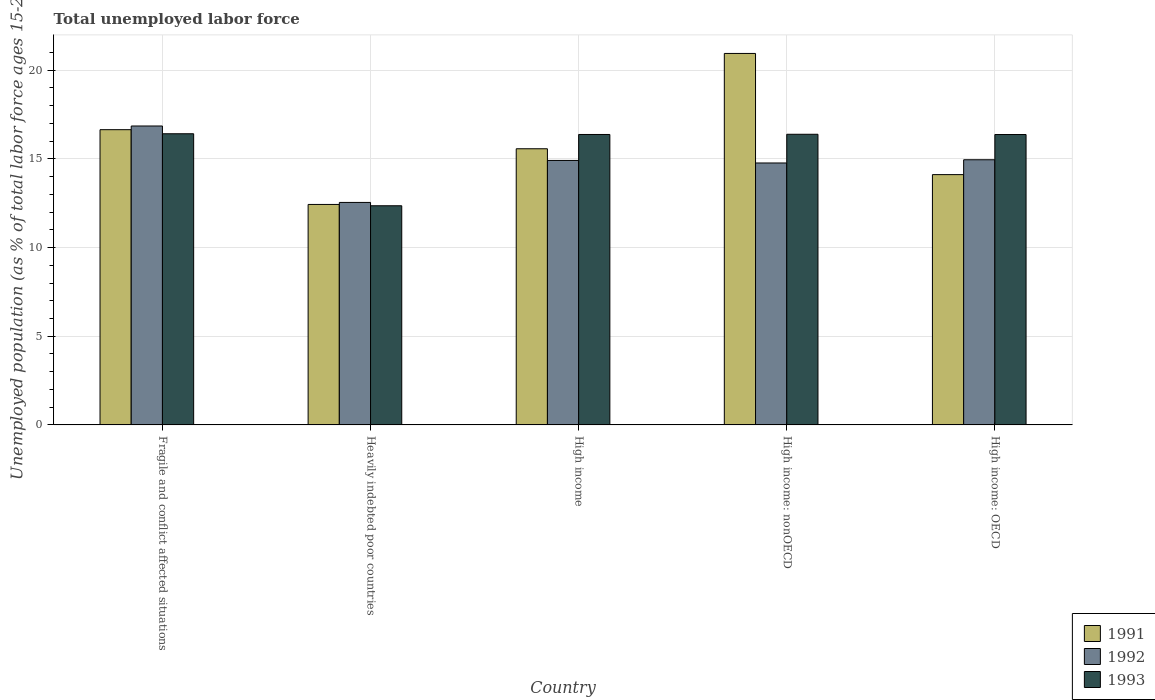How many groups of bars are there?
Ensure brevity in your answer.  5. Are the number of bars on each tick of the X-axis equal?
Make the answer very short. Yes. How many bars are there on the 2nd tick from the right?
Make the answer very short. 3. What is the label of the 2nd group of bars from the left?
Provide a short and direct response. Heavily indebted poor countries. In how many cases, is the number of bars for a given country not equal to the number of legend labels?
Offer a terse response. 0. What is the percentage of unemployed population in in 1991 in High income: nonOECD?
Your answer should be very brief. 20.94. Across all countries, what is the maximum percentage of unemployed population in in 1993?
Give a very brief answer. 16.42. Across all countries, what is the minimum percentage of unemployed population in in 1992?
Keep it short and to the point. 12.54. In which country was the percentage of unemployed population in in 1993 maximum?
Your answer should be compact. Fragile and conflict affected situations. In which country was the percentage of unemployed population in in 1992 minimum?
Offer a terse response. Heavily indebted poor countries. What is the total percentage of unemployed population in in 1991 in the graph?
Offer a very short reply. 79.7. What is the difference between the percentage of unemployed population in in 1993 in Heavily indebted poor countries and that in High income: nonOECD?
Your answer should be very brief. -4.03. What is the difference between the percentage of unemployed population in in 1991 in High income and the percentage of unemployed population in in 1993 in High income: OECD?
Provide a succinct answer. -0.8. What is the average percentage of unemployed population in in 1993 per country?
Give a very brief answer. 15.58. What is the difference between the percentage of unemployed population in of/in 1993 and percentage of unemployed population in of/in 1991 in Fragile and conflict affected situations?
Provide a short and direct response. -0.23. What is the ratio of the percentage of unemployed population in in 1993 in Heavily indebted poor countries to that in High income: nonOECD?
Provide a succinct answer. 0.75. Is the percentage of unemployed population in in 1991 in Fragile and conflict affected situations less than that in High income: nonOECD?
Your answer should be very brief. Yes. What is the difference between the highest and the second highest percentage of unemployed population in in 1991?
Your answer should be very brief. -4.3. What is the difference between the highest and the lowest percentage of unemployed population in in 1993?
Offer a terse response. 4.06. In how many countries, is the percentage of unemployed population in in 1993 greater than the average percentage of unemployed population in in 1993 taken over all countries?
Offer a very short reply. 4. What does the 2nd bar from the left in Heavily indebted poor countries represents?
Offer a terse response. 1992. What does the 2nd bar from the right in High income represents?
Make the answer very short. 1992. Are all the bars in the graph horizontal?
Offer a very short reply. No. How many countries are there in the graph?
Ensure brevity in your answer.  5. What is the difference between two consecutive major ticks on the Y-axis?
Offer a very short reply. 5. Does the graph contain grids?
Your answer should be compact. Yes. How are the legend labels stacked?
Offer a very short reply. Vertical. What is the title of the graph?
Offer a very short reply. Total unemployed labor force. What is the label or title of the Y-axis?
Your answer should be very brief. Unemployed population (as % of total labor force ages 15-24). What is the Unemployed population (as % of total labor force ages 15-24) of 1991 in Fragile and conflict affected situations?
Provide a short and direct response. 16.65. What is the Unemployed population (as % of total labor force ages 15-24) of 1992 in Fragile and conflict affected situations?
Provide a succinct answer. 16.85. What is the Unemployed population (as % of total labor force ages 15-24) in 1993 in Fragile and conflict affected situations?
Give a very brief answer. 16.42. What is the Unemployed population (as % of total labor force ages 15-24) of 1991 in Heavily indebted poor countries?
Ensure brevity in your answer.  12.43. What is the Unemployed population (as % of total labor force ages 15-24) in 1992 in Heavily indebted poor countries?
Keep it short and to the point. 12.54. What is the Unemployed population (as % of total labor force ages 15-24) in 1993 in Heavily indebted poor countries?
Keep it short and to the point. 12.36. What is the Unemployed population (as % of total labor force ages 15-24) of 1991 in High income?
Provide a succinct answer. 15.57. What is the Unemployed population (as % of total labor force ages 15-24) in 1992 in High income?
Provide a short and direct response. 14.91. What is the Unemployed population (as % of total labor force ages 15-24) of 1993 in High income?
Your response must be concise. 16.38. What is the Unemployed population (as % of total labor force ages 15-24) in 1991 in High income: nonOECD?
Your answer should be very brief. 20.94. What is the Unemployed population (as % of total labor force ages 15-24) in 1992 in High income: nonOECD?
Your answer should be very brief. 14.77. What is the Unemployed population (as % of total labor force ages 15-24) in 1993 in High income: nonOECD?
Offer a very short reply. 16.39. What is the Unemployed population (as % of total labor force ages 15-24) of 1991 in High income: OECD?
Make the answer very short. 14.11. What is the Unemployed population (as % of total labor force ages 15-24) in 1992 in High income: OECD?
Offer a very short reply. 14.95. What is the Unemployed population (as % of total labor force ages 15-24) of 1993 in High income: OECD?
Offer a terse response. 16.37. Across all countries, what is the maximum Unemployed population (as % of total labor force ages 15-24) in 1991?
Your answer should be compact. 20.94. Across all countries, what is the maximum Unemployed population (as % of total labor force ages 15-24) in 1992?
Provide a succinct answer. 16.85. Across all countries, what is the maximum Unemployed population (as % of total labor force ages 15-24) of 1993?
Your answer should be compact. 16.42. Across all countries, what is the minimum Unemployed population (as % of total labor force ages 15-24) in 1991?
Your answer should be compact. 12.43. Across all countries, what is the minimum Unemployed population (as % of total labor force ages 15-24) of 1992?
Give a very brief answer. 12.54. Across all countries, what is the minimum Unemployed population (as % of total labor force ages 15-24) in 1993?
Keep it short and to the point. 12.36. What is the total Unemployed population (as % of total labor force ages 15-24) of 1991 in the graph?
Offer a terse response. 79.7. What is the total Unemployed population (as % of total labor force ages 15-24) in 1992 in the graph?
Provide a succinct answer. 74.03. What is the total Unemployed population (as % of total labor force ages 15-24) in 1993 in the graph?
Give a very brief answer. 77.91. What is the difference between the Unemployed population (as % of total labor force ages 15-24) of 1991 in Fragile and conflict affected situations and that in Heavily indebted poor countries?
Keep it short and to the point. 4.22. What is the difference between the Unemployed population (as % of total labor force ages 15-24) of 1992 in Fragile and conflict affected situations and that in Heavily indebted poor countries?
Keep it short and to the point. 4.31. What is the difference between the Unemployed population (as % of total labor force ages 15-24) of 1993 in Fragile and conflict affected situations and that in Heavily indebted poor countries?
Offer a terse response. 4.06. What is the difference between the Unemployed population (as % of total labor force ages 15-24) in 1991 in Fragile and conflict affected situations and that in High income?
Provide a succinct answer. 1.08. What is the difference between the Unemployed population (as % of total labor force ages 15-24) in 1992 in Fragile and conflict affected situations and that in High income?
Provide a short and direct response. 1.94. What is the difference between the Unemployed population (as % of total labor force ages 15-24) in 1993 in Fragile and conflict affected situations and that in High income?
Give a very brief answer. 0.04. What is the difference between the Unemployed population (as % of total labor force ages 15-24) of 1991 in Fragile and conflict affected situations and that in High income: nonOECD?
Your response must be concise. -4.3. What is the difference between the Unemployed population (as % of total labor force ages 15-24) of 1992 in Fragile and conflict affected situations and that in High income: nonOECD?
Give a very brief answer. 2.09. What is the difference between the Unemployed population (as % of total labor force ages 15-24) of 1993 in Fragile and conflict affected situations and that in High income: nonOECD?
Make the answer very short. 0.03. What is the difference between the Unemployed population (as % of total labor force ages 15-24) in 1991 in Fragile and conflict affected situations and that in High income: OECD?
Your response must be concise. 2.53. What is the difference between the Unemployed population (as % of total labor force ages 15-24) in 1992 in Fragile and conflict affected situations and that in High income: OECD?
Your response must be concise. 1.9. What is the difference between the Unemployed population (as % of total labor force ages 15-24) in 1993 in Fragile and conflict affected situations and that in High income: OECD?
Give a very brief answer. 0.04. What is the difference between the Unemployed population (as % of total labor force ages 15-24) in 1991 in Heavily indebted poor countries and that in High income?
Make the answer very short. -3.14. What is the difference between the Unemployed population (as % of total labor force ages 15-24) of 1992 in Heavily indebted poor countries and that in High income?
Keep it short and to the point. -2.37. What is the difference between the Unemployed population (as % of total labor force ages 15-24) of 1993 in Heavily indebted poor countries and that in High income?
Ensure brevity in your answer.  -4.02. What is the difference between the Unemployed population (as % of total labor force ages 15-24) in 1991 in Heavily indebted poor countries and that in High income: nonOECD?
Offer a very short reply. -8.51. What is the difference between the Unemployed population (as % of total labor force ages 15-24) of 1992 in Heavily indebted poor countries and that in High income: nonOECD?
Your answer should be compact. -2.22. What is the difference between the Unemployed population (as % of total labor force ages 15-24) of 1993 in Heavily indebted poor countries and that in High income: nonOECD?
Ensure brevity in your answer.  -4.03. What is the difference between the Unemployed population (as % of total labor force ages 15-24) of 1991 in Heavily indebted poor countries and that in High income: OECD?
Make the answer very short. -1.68. What is the difference between the Unemployed population (as % of total labor force ages 15-24) in 1992 in Heavily indebted poor countries and that in High income: OECD?
Offer a very short reply. -2.41. What is the difference between the Unemployed population (as % of total labor force ages 15-24) in 1993 in Heavily indebted poor countries and that in High income: OECD?
Keep it short and to the point. -4.02. What is the difference between the Unemployed population (as % of total labor force ages 15-24) in 1991 in High income and that in High income: nonOECD?
Ensure brevity in your answer.  -5.37. What is the difference between the Unemployed population (as % of total labor force ages 15-24) in 1992 in High income and that in High income: nonOECD?
Your answer should be compact. 0.14. What is the difference between the Unemployed population (as % of total labor force ages 15-24) of 1993 in High income and that in High income: nonOECD?
Your response must be concise. -0.01. What is the difference between the Unemployed population (as % of total labor force ages 15-24) of 1991 in High income and that in High income: OECD?
Provide a short and direct response. 1.46. What is the difference between the Unemployed population (as % of total labor force ages 15-24) in 1992 in High income and that in High income: OECD?
Ensure brevity in your answer.  -0.04. What is the difference between the Unemployed population (as % of total labor force ages 15-24) of 1993 in High income and that in High income: OECD?
Give a very brief answer. 0. What is the difference between the Unemployed population (as % of total labor force ages 15-24) in 1991 in High income: nonOECD and that in High income: OECD?
Ensure brevity in your answer.  6.83. What is the difference between the Unemployed population (as % of total labor force ages 15-24) of 1992 in High income: nonOECD and that in High income: OECD?
Your answer should be very brief. -0.18. What is the difference between the Unemployed population (as % of total labor force ages 15-24) of 1993 in High income: nonOECD and that in High income: OECD?
Ensure brevity in your answer.  0.01. What is the difference between the Unemployed population (as % of total labor force ages 15-24) of 1991 in Fragile and conflict affected situations and the Unemployed population (as % of total labor force ages 15-24) of 1992 in Heavily indebted poor countries?
Ensure brevity in your answer.  4.1. What is the difference between the Unemployed population (as % of total labor force ages 15-24) of 1991 in Fragile and conflict affected situations and the Unemployed population (as % of total labor force ages 15-24) of 1993 in Heavily indebted poor countries?
Give a very brief answer. 4.29. What is the difference between the Unemployed population (as % of total labor force ages 15-24) of 1992 in Fragile and conflict affected situations and the Unemployed population (as % of total labor force ages 15-24) of 1993 in Heavily indebted poor countries?
Offer a terse response. 4.5. What is the difference between the Unemployed population (as % of total labor force ages 15-24) in 1991 in Fragile and conflict affected situations and the Unemployed population (as % of total labor force ages 15-24) in 1992 in High income?
Your answer should be compact. 1.73. What is the difference between the Unemployed population (as % of total labor force ages 15-24) in 1991 in Fragile and conflict affected situations and the Unemployed population (as % of total labor force ages 15-24) in 1993 in High income?
Keep it short and to the point. 0.27. What is the difference between the Unemployed population (as % of total labor force ages 15-24) of 1992 in Fragile and conflict affected situations and the Unemployed population (as % of total labor force ages 15-24) of 1993 in High income?
Your response must be concise. 0.48. What is the difference between the Unemployed population (as % of total labor force ages 15-24) of 1991 in Fragile and conflict affected situations and the Unemployed population (as % of total labor force ages 15-24) of 1992 in High income: nonOECD?
Your answer should be very brief. 1.88. What is the difference between the Unemployed population (as % of total labor force ages 15-24) in 1991 in Fragile and conflict affected situations and the Unemployed population (as % of total labor force ages 15-24) in 1993 in High income: nonOECD?
Give a very brief answer. 0.26. What is the difference between the Unemployed population (as % of total labor force ages 15-24) in 1992 in Fragile and conflict affected situations and the Unemployed population (as % of total labor force ages 15-24) in 1993 in High income: nonOECD?
Ensure brevity in your answer.  0.47. What is the difference between the Unemployed population (as % of total labor force ages 15-24) of 1991 in Fragile and conflict affected situations and the Unemployed population (as % of total labor force ages 15-24) of 1992 in High income: OECD?
Make the answer very short. 1.7. What is the difference between the Unemployed population (as % of total labor force ages 15-24) in 1991 in Fragile and conflict affected situations and the Unemployed population (as % of total labor force ages 15-24) in 1993 in High income: OECD?
Your response must be concise. 0.27. What is the difference between the Unemployed population (as % of total labor force ages 15-24) of 1992 in Fragile and conflict affected situations and the Unemployed population (as % of total labor force ages 15-24) of 1993 in High income: OECD?
Your answer should be compact. 0.48. What is the difference between the Unemployed population (as % of total labor force ages 15-24) of 1991 in Heavily indebted poor countries and the Unemployed population (as % of total labor force ages 15-24) of 1992 in High income?
Provide a short and direct response. -2.48. What is the difference between the Unemployed population (as % of total labor force ages 15-24) in 1991 in Heavily indebted poor countries and the Unemployed population (as % of total labor force ages 15-24) in 1993 in High income?
Your answer should be compact. -3.95. What is the difference between the Unemployed population (as % of total labor force ages 15-24) of 1992 in Heavily indebted poor countries and the Unemployed population (as % of total labor force ages 15-24) of 1993 in High income?
Offer a terse response. -3.83. What is the difference between the Unemployed population (as % of total labor force ages 15-24) in 1991 in Heavily indebted poor countries and the Unemployed population (as % of total labor force ages 15-24) in 1992 in High income: nonOECD?
Provide a succinct answer. -2.34. What is the difference between the Unemployed population (as % of total labor force ages 15-24) of 1991 in Heavily indebted poor countries and the Unemployed population (as % of total labor force ages 15-24) of 1993 in High income: nonOECD?
Provide a succinct answer. -3.96. What is the difference between the Unemployed population (as % of total labor force ages 15-24) in 1992 in Heavily indebted poor countries and the Unemployed population (as % of total labor force ages 15-24) in 1993 in High income: nonOECD?
Your response must be concise. -3.84. What is the difference between the Unemployed population (as % of total labor force ages 15-24) in 1991 in Heavily indebted poor countries and the Unemployed population (as % of total labor force ages 15-24) in 1992 in High income: OECD?
Provide a short and direct response. -2.52. What is the difference between the Unemployed population (as % of total labor force ages 15-24) in 1991 in Heavily indebted poor countries and the Unemployed population (as % of total labor force ages 15-24) in 1993 in High income: OECD?
Provide a short and direct response. -3.94. What is the difference between the Unemployed population (as % of total labor force ages 15-24) of 1992 in Heavily indebted poor countries and the Unemployed population (as % of total labor force ages 15-24) of 1993 in High income: OECD?
Your answer should be compact. -3.83. What is the difference between the Unemployed population (as % of total labor force ages 15-24) in 1991 in High income and the Unemployed population (as % of total labor force ages 15-24) in 1992 in High income: nonOECD?
Your answer should be very brief. 0.8. What is the difference between the Unemployed population (as % of total labor force ages 15-24) of 1991 in High income and the Unemployed population (as % of total labor force ages 15-24) of 1993 in High income: nonOECD?
Provide a short and direct response. -0.82. What is the difference between the Unemployed population (as % of total labor force ages 15-24) of 1992 in High income and the Unemployed population (as % of total labor force ages 15-24) of 1993 in High income: nonOECD?
Offer a terse response. -1.48. What is the difference between the Unemployed population (as % of total labor force ages 15-24) in 1991 in High income and the Unemployed population (as % of total labor force ages 15-24) in 1992 in High income: OECD?
Give a very brief answer. 0.62. What is the difference between the Unemployed population (as % of total labor force ages 15-24) in 1991 in High income and the Unemployed population (as % of total labor force ages 15-24) in 1993 in High income: OECD?
Your answer should be very brief. -0.8. What is the difference between the Unemployed population (as % of total labor force ages 15-24) in 1992 in High income and the Unemployed population (as % of total labor force ages 15-24) in 1993 in High income: OECD?
Your answer should be very brief. -1.46. What is the difference between the Unemployed population (as % of total labor force ages 15-24) of 1991 in High income: nonOECD and the Unemployed population (as % of total labor force ages 15-24) of 1992 in High income: OECD?
Make the answer very short. 5.99. What is the difference between the Unemployed population (as % of total labor force ages 15-24) of 1991 in High income: nonOECD and the Unemployed population (as % of total labor force ages 15-24) of 1993 in High income: OECD?
Give a very brief answer. 4.57. What is the difference between the Unemployed population (as % of total labor force ages 15-24) in 1992 in High income: nonOECD and the Unemployed population (as % of total labor force ages 15-24) in 1993 in High income: OECD?
Offer a very short reply. -1.6. What is the average Unemployed population (as % of total labor force ages 15-24) of 1991 per country?
Ensure brevity in your answer.  15.94. What is the average Unemployed population (as % of total labor force ages 15-24) in 1992 per country?
Your answer should be compact. 14.81. What is the average Unemployed population (as % of total labor force ages 15-24) of 1993 per country?
Keep it short and to the point. 15.58. What is the difference between the Unemployed population (as % of total labor force ages 15-24) in 1991 and Unemployed population (as % of total labor force ages 15-24) in 1992 in Fragile and conflict affected situations?
Ensure brevity in your answer.  -0.21. What is the difference between the Unemployed population (as % of total labor force ages 15-24) in 1991 and Unemployed population (as % of total labor force ages 15-24) in 1993 in Fragile and conflict affected situations?
Ensure brevity in your answer.  0.23. What is the difference between the Unemployed population (as % of total labor force ages 15-24) in 1992 and Unemployed population (as % of total labor force ages 15-24) in 1993 in Fragile and conflict affected situations?
Your response must be concise. 0.44. What is the difference between the Unemployed population (as % of total labor force ages 15-24) of 1991 and Unemployed population (as % of total labor force ages 15-24) of 1992 in Heavily indebted poor countries?
Offer a very short reply. -0.11. What is the difference between the Unemployed population (as % of total labor force ages 15-24) of 1991 and Unemployed population (as % of total labor force ages 15-24) of 1993 in Heavily indebted poor countries?
Make the answer very short. 0.07. What is the difference between the Unemployed population (as % of total labor force ages 15-24) of 1992 and Unemployed population (as % of total labor force ages 15-24) of 1993 in Heavily indebted poor countries?
Give a very brief answer. 0.19. What is the difference between the Unemployed population (as % of total labor force ages 15-24) of 1991 and Unemployed population (as % of total labor force ages 15-24) of 1992 in High income?
Give a very brief answer. 0.66. What is the difference between the Unemployed population (as % of total labor force ages 15-24) of 1991 and Unemployed population (as % of total labor force ages 15-24) of 1993 in High income?
Give a very brief answer. -0.81. What is the difference between the Unemployed population (as % of total labor force ages 15-24) of 1992 and Unemployed population (as % of total labor force ages 15-24) of 1993 in High income?
Make the answer very short. -1.46. What is the difference between the Unemployed population (as % of total labor force ages 15-24) of 1991 and Unemployed population (as % of total labor force ages 15-24) of 1992 in High income: nonOECD?
Offer a very short reply. 6.18. What is the difference between the Unemployed population (as % of total labor force ages 15-24) in 1991 and Unemployed population (as % of total labor force ages 15-24) in 1993 in High income: nonOECD?
Offer a terse response. 4.56. What is the difference between the Unemployed population (as % of total labor force ages 15-24) of 1992 and Unemployed population (as % of total labor force ages 15-24) of 1993 in High income: nonOECD?
Provide a succinct answer. -1.62. What is the difference between the Unemployed population (as % of total labor force ages 15-24) in 1991 and Unemployed population (as % of total labor force ages 15-24) in 1992 in High income: OECD?
Make the answer very short. -0.84. What is the difference between the Unemployed population (as % of total labor force ages 15-24) in 1991 and Unemployed population (as % of total labor force ages 15-24) in 1993 in High income: OECD?
Provide a succinct answer. -2.26. What is the difference between the Unemployed population (as % of total labor force ages 15-24) in 1992 and Unemployed population (as % of total labor force ages 15-24) in 1993 in High income: OECD?
Your answer should be compact. -1.42. What is the ratio of the Unemployed population (as % of total labor force ages 15-24) of 1991 in Fragile and conflict affected situations to that in Heavily indebted poor countries?
Your answer should be compact. 1.34. What is the ratio of the Unemployed population (as % of total labor force ages 15-24) in 1992 in Fragile and conflict affected situations to that in Heavily indebted poor countries?
Offer a terse response. 1.34. What is the ratio of the Unemployed population (as % of total labor force ages 15-24) in 1993 in Fragile and conflict affected situations to that in Heavily indebted poor countries?
Your answer should be very brief. 1.33. What is the ratio of the Unemployed population (as % of total labor force ages 15-24) in 1991 in Fragile and conflict affected situations to that in High income?
Make the answer very short. 1.07. What is the ratio of the Unemployed population (as % of total labor force ages 15-24) of 1992 in Fragile and conflict affected situations to that in High income?
Your response must be concise. 1.13. What is the ratio of the Unemployed population (as % of total labor force ages 15-24) of 1993 in Fragile and conflict affected situations to that in High income?
Offer a very short reply. 1. What is the ratio of the Unemployed population (as % of total labor force ages 15-24) in 1991 in Fragile and conflict affected situations to that in High income: nonOECD?
Make the answer very short. 0.79. What is the ratio of the Unemployed population (as % of total labor force ages 15-24) in 1992 in Fragile and conflict affected situations to that in High income: nonOECD?
Your response must be concise. 1.14. What is the ratio of the Unemployed population (as % of total labor force ages 15-24) of 1993 in Fragile and conflict affected situations to that in High income: nonOECD?
Give a very brief answer. 1. What is the ratio of the Unemployed population (as % of total labor force ages 15-24) in 1991 in Fragile and conflict affected situations to that in High income: OECD?
Your response must be concise. 1.18. What is the ratio of the Unemployed population (as % of total labor force ages 15-24) of 1992 in Fragile and conflict affected situations to that in High income: OECD?
Your answer should be compact. 1.13. What is the ratio of the Unemployed population (as % of total labor force ages 15-24) of 1993 in Fragile and conflict affected situations to that in High income: OECD?
Your answer should be very brief. 1. What is the ratio of the Unemployed population (as % of total labor force ages 15-24) in 1991 in Heavily indebted poor countries to that in High income?
Offer a terse response. 0.8. What is the ratio of the Unemployed population (as % of total labor force ages 15-24) of 1992 in Heavily indebted poor countries to that in High income?
Your answer should be very brief. 0.84. What is the ratio of the Unemployed population (as % of total labor force ages 15-24) of 1993 in Heavily indebted poor countries to that in High income?
Provide a succinct answer. 0.75. What is the ratio of the Unemployed population (as % of total labor force ages 15-24) of 1991 in Heavily indebted poor countries to that in High income: nonOECD?
Keep it short and to the point. 0.59. What is the ratio of the Unemployed population (as % of total labor force ages 15-24) of 1992 in Heavily indebted poor countries to that in High income: nonOECD?
Your answer should be compact. 0.85. What is the ratio of the Unemployed population (as % of total labor force ages 15-24) of 1993 in Heavily indebted poor countries to that in High income: nonOECD?
Ensure brevity in your answer.  0.75. What is the ratio of the Unemployed population (as % of total labor force ages 15-24) in 1991 in Heavily indebted poor countries to that in High income: OECD?
Provide a short and direct response. 0.88. What is the ratio of the Unemployed population (as % of total labor force ages 15-24) in 1992 in Heavily indebted poor countries to that in High income: OECD?
Give a very brief answer. 0.84. What is the ratio of the Unemployed population (as % of total labor force ages 15-24) in 1993 in Heavily indebted poor countries to that in High income: OECD?
Your answer should be compact. 0.75. What is the ratio of the Unemployed population (as % of total labor force ages 15-24) of 1991 in High income to that in High income: nonOECD?
Provide a short and direct response. 0.74. What is the ratio of the Unemployed population (as % of total labor force ages 15-24) of 1992 in High income to that in High income: nonOECD?
Make the answer very short. 1.01. What is the ratio of the Unemployed population (as % of total labor force ages 15-24) of 1991 in High income to that in High income: OECD?
Offer a terse response. 1.1. What is the ratio of the Unemployed population (as % of total labor force ages 15-24) of 1993 in High income to that in High income: OECD?
Your response must be concise. 1. What is the ratio of the Unemployed population (as % of total labor force ages 15-24) of 1991 in High income: nonOECD to that in High income: OECD?
Your answer should be compact. 1.48. What is the ratio of the Unemployed population (as % of total labor force ages 15-24) of 1992 in High income: nonOECD to that in High income: OECD?
Offer a terse response. 0.99. What is the ratio of the Unemployed population (as % of total labor force ages 15-24) of 1993 in High income: nonOECD to that in High income: OECD?
Offer a very short reply. 1. What is the difference between the highest and the second highest Unemployed population (as % of total labor force ages 15-24) of 1991?
Offer a terse response. 4.3. What is the difference between the highest and the second highest Unemployed population (as % of total labor force ages 15-24) of 1992?
Provide a succinct answer. 1.9. What is the difference between the highest and the second highest Unemployed population (as % of total labor force ages 15-24) of 1993?
Your response must be concise. 0.03. What is the difference between the highest and the lowest Unemployed population (as % of total labor force ages 15-24) in 1991?
Your response must be concise. 8.51. What is the difference between the highest and the lowest Unemployed population (as % of total labor force ages 15-24) of 1992?
Provide a short and direct response. 4.31. What is the difference between the highest and the lowest Unemployed population (as % of total labor force ages 15-24) of 1993?
Your answer should be very brief. 4.06. 